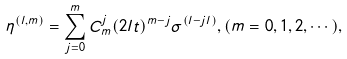<formula> <loc_0><loc_0><loc_500><loc_500>\eta ^ { ( l , m ) } = \sum ^ { m } _ { j = 0 } C ^ { j } _ { m } ( 2 l t ) ^ { m - j } \sigma ^ { ( l - j l ) } , ( m = 0 , 1 , 2 , \cdots ) ,</formula> 